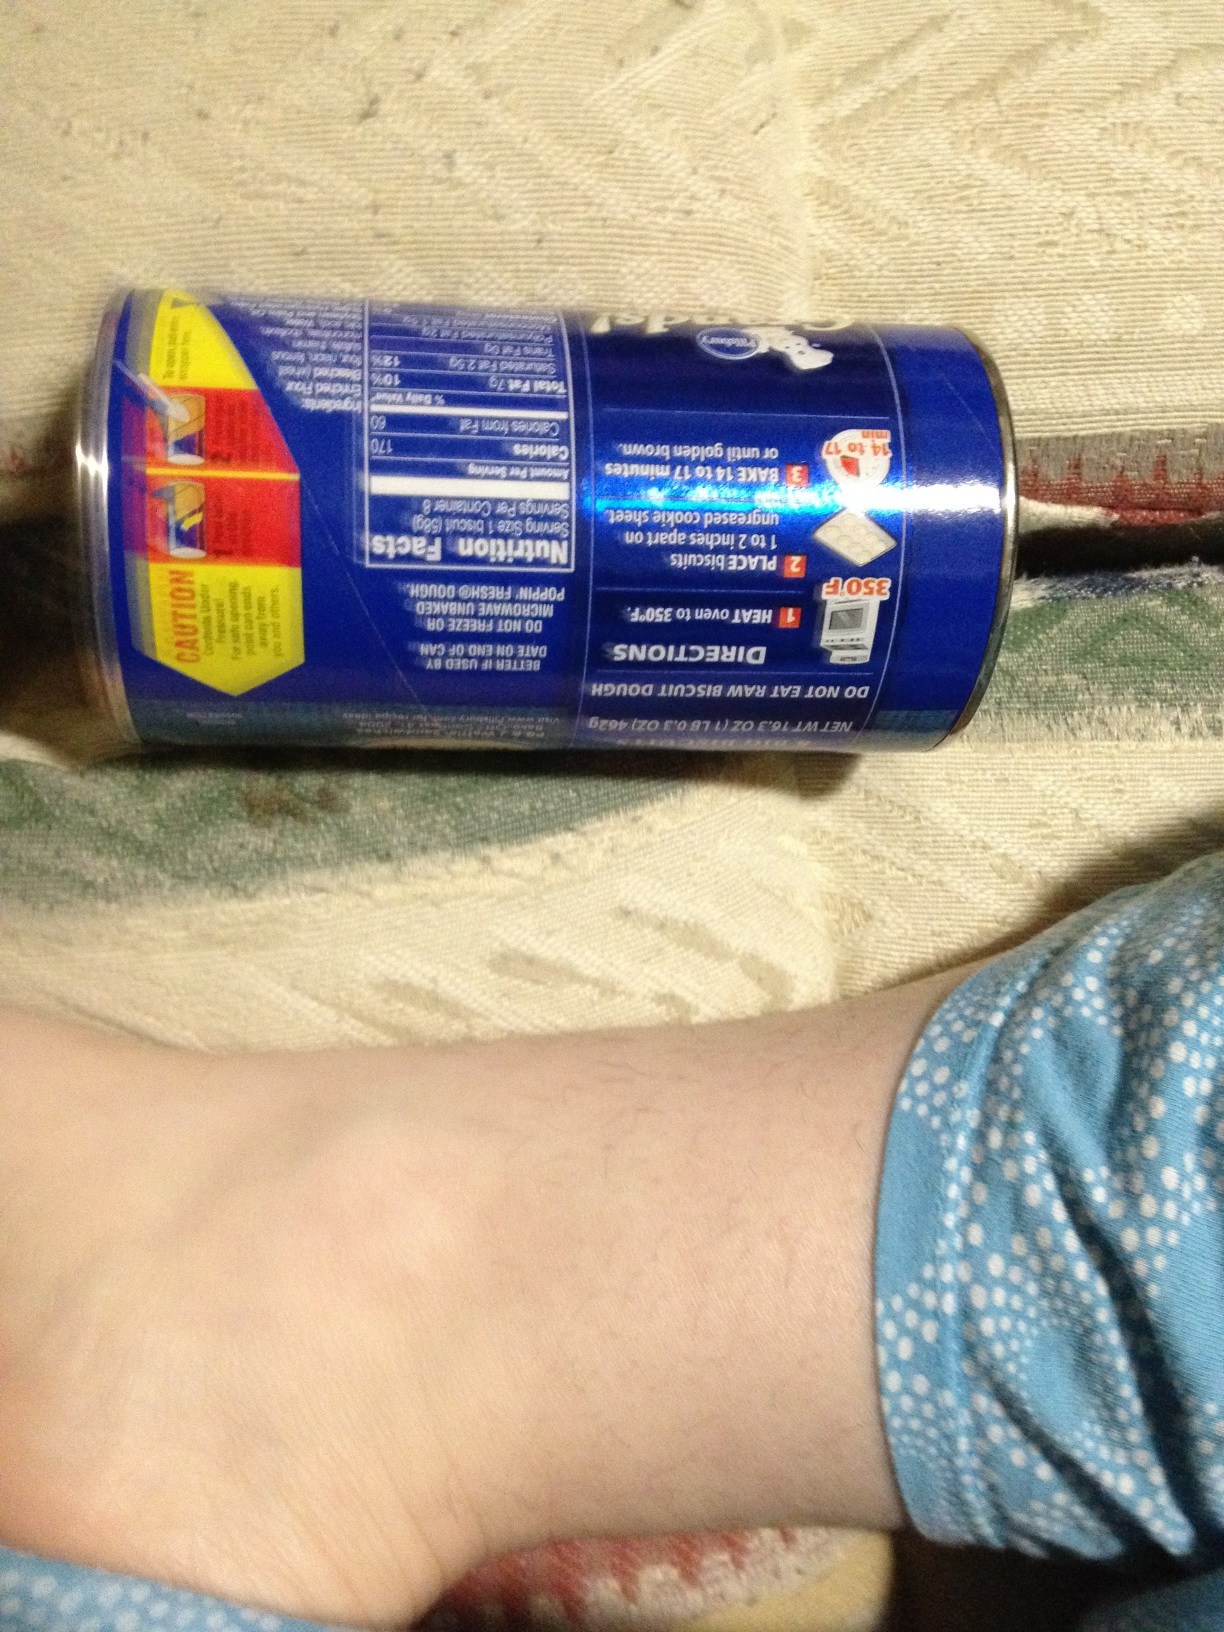Tell me a wild and imaginative use for these biscuits. Imagine using these biscuits to build a miniature, edible house. Each biscuit becomes a brick in the walls of a dream cottage, and the icing serves as mortar. The roof is made from caramelized biscuit tiles, perfectly golden and crisp. Inside, the rooms are decorated with edible furniture made from sugar cookie and candy, and tiny marshmallow pillows. This biscuit house stands as the centerpiece of a magical winter feast, gleaming under the twinkling fairy lights, inviting everyone to take a bite and step into the world of their sweetest dreams. 